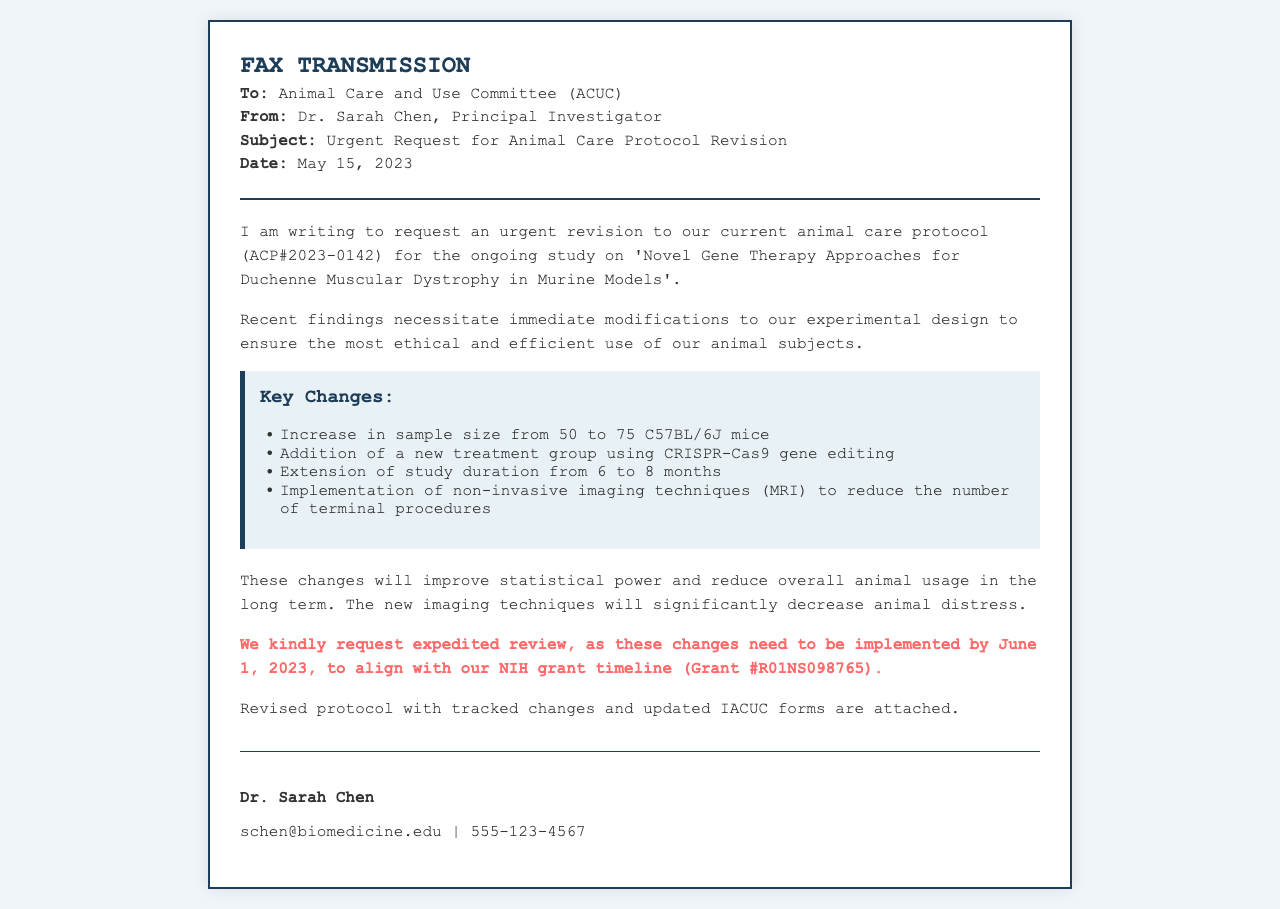what is the subject of the fax? The subject is stated in the header of the document and mentions the nature of the request, which is for a protocol revision.
Answer: Urgent Request for Animal Care Protocol Revision who is the sender of the fax? The sender is identified at the top of the document as the Principal Investigator.
Answer: Dr. Sarah Chen what is the protocol number mentioned? The protocol number is included in the body of the document and refers to the specific animal care protocol being revised.
Answer: ACP#2023-0142 by what date must the revisions be implemented? The deadline for implementing the changes is clearly stated in the document, emphasizing the urgency of the request.
Answer: June 1, 2023 what is the increase in sample size? The increase in sample size is specified in the list of key changes and shows the planned adjustment to the number of animal subjects.
Answer: from 50 to 75 C57BL/6J mice what new technique is being added to the protocol? The document highlights a new approach intended to enhance the study's design, making it a significant change.
Answer: CRISPR-Cas9 gene editing how long will the study duration be extended? The duration extension is mentioned as part of the revisions to improve the study timeline.
Answer: from 6 to 8 months what is being implemented to reduce terminal procedures? The document specifies a new method to lower the number of invasive procedures on the animals, which is a key focus of the revisions.
Answer: non-invasive imaging techniques (MRI) what is the anticipated outcome of these changes? The body of the document outlines the expected benefits of the proposed adjustments to the protocol.
Answer: improve statistical power and reduce overall animal usage 